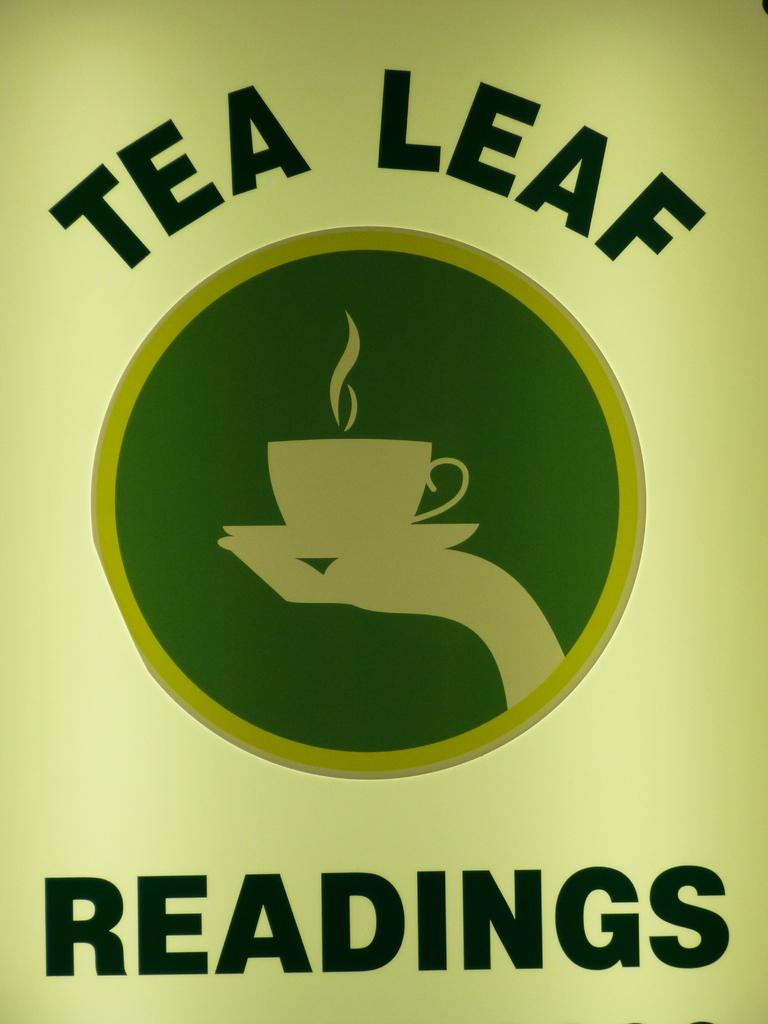Provide a one-sentence caption for the provided image. Tea Leaf Readings is written around a logo of a hand holding a cup on a saucer. 